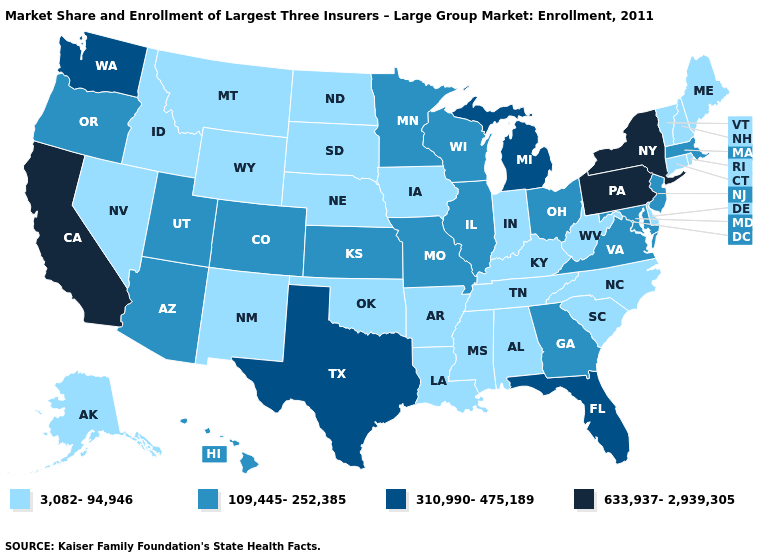What is the highest value in states that border Connecticut?
Concise answer only. 633,937-2,939,305. Among the states that border Massachusetts , does New Hampshire have the lowest value?
Short answer required. Yes. What is the value of Delaware?
Give a very brief answer. 3,082-94,946. What is the value of Colorado?
Quick response, please. 109,445-252,385. Name the states that have a value in the range 3,082-94,946?
Quick response, please. Alabama, Alaska, Arkansas, Connecticut, Delaware, Idaho, Indiana, Iowa, Kentucky, Louisiana, Maine, Mississippi, Montana, Nebraska, Nevada, New Hampshire, New Mexico, North Carolina, North Dakota, Oklahoma, Rhode Island, South Carolina, South Dakota, Tennessee, Vermont, West Virginia, Wyoming. What is the value of Connecticut?
Give a very brief answer. 3,082-94,946. What is the value of South Carolina?
Concise answer only. 3,082-94,946. Does Nevada have the highest value in the USA?
Short answer required. No. What is the value of North Carolina?
Short answer required. 3,082-94,946. What is the value of Delaware?
Answer briefly. 3,082-94,946. What is the highest value in the USA?
Write a very short answer. 633,937-2,939,305. Does Michigan have the highest value in the MidWest?
Keep it brief. Yes. What is the value of New York?
Be succinct. 633,937-2,939,305. What is the lowest value in states that border North Dakota?
Give a very brief answer. 3,082-94,946. What is the lowest value in the Northeast?
Concise answer only. 3,082-94,946. 